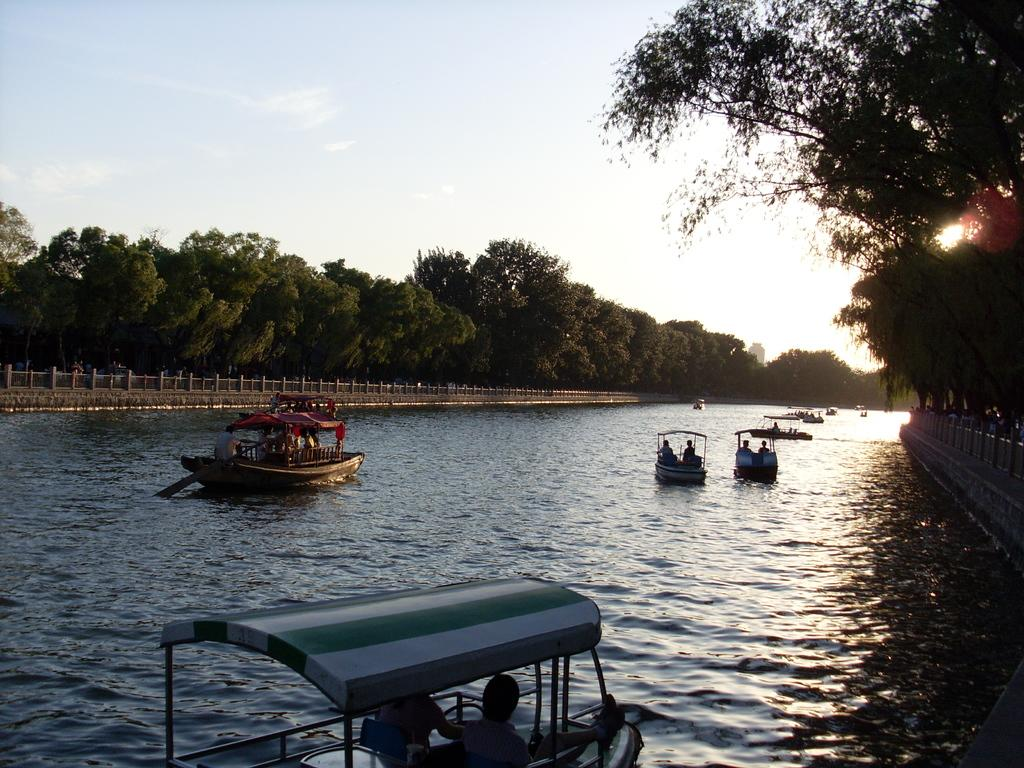What is the primary element in the image? There is a water surface in the image. What is on the water surface? There are boats on the water. What type of vegetation can be seen in the image? There are trees visible in the image. What is visible in the sky in the image? Clouds are present in the sky. Can you see a bone in the image? There is no bone present in the image. Who is the friend with the person in the image? There is no person present in the image, so it is not possible to identify a friend. 